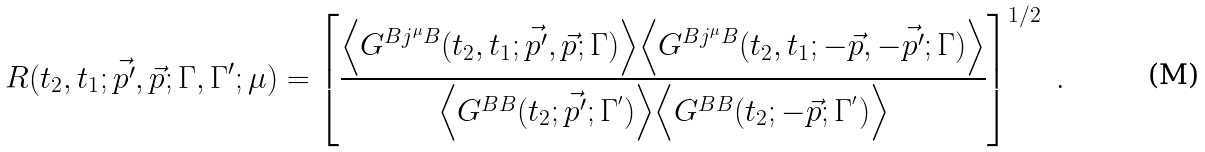<formula> <loc_0><loc_0><loc_500><loc_500>R ( t _ { 2 } , t _ { 1 } ; \vec { p ^ { \prime } } , \vec { p } ; \Gamma , \Gamma ^ { \prime } ; \mu ) = \left [ \frac { \Big < G ^ { B j ^ { \mu } B } ( t _ { 2 } , t _ { 1 } ; \vec { p ^ { \prime } } , \vec { p } ; \Gamma ) \Big > \Big < G ^ { B j ^ { \mu } B } ( t _ { 2 } , t _ { 1 } ; - \vec { p } , - \vec { p ^ { \prime } } ; \Gamma ) \Big > } { \Big < G ^ { B B } ( t _ { 2 } ; \vec { p ^ { \prime } } ; \Gamma ^ { ^ { \prime } } ) \Big > \Big < G ^ { B B } ( t _ { 2 } ; - \vec { p } ; \Gamma ^ { ^ { \prime } } ) \Big > } \right ] ^ { 1 / 2 } \ .</formula> 